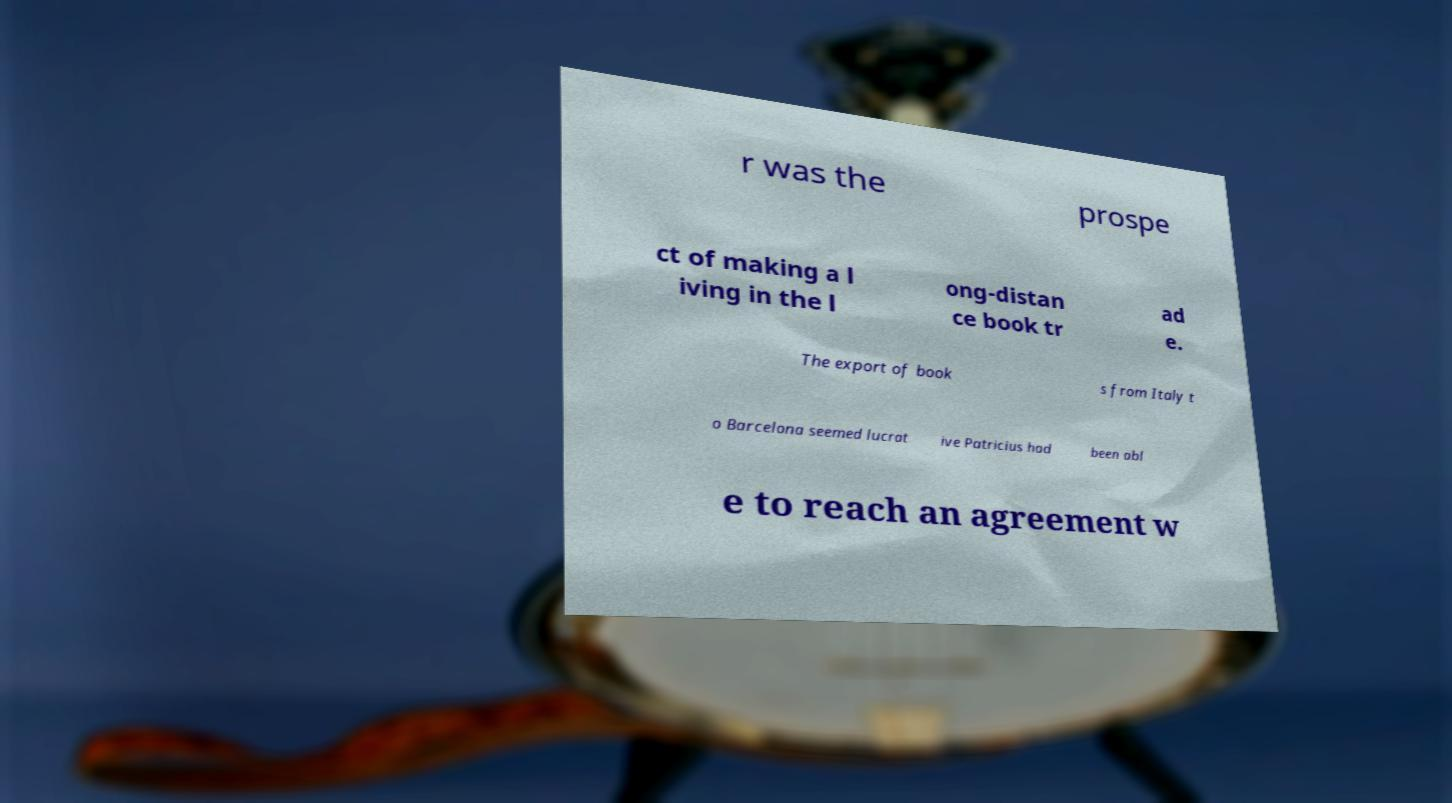Please identify and transcribe the text found in this image. r was the prospe ct of making a l iving in the l ong-distan ce book tr ad e. The export of book s from Italy t o Barcelona seemed lucrat ive Patricius had been abl e to reach an agreement w 